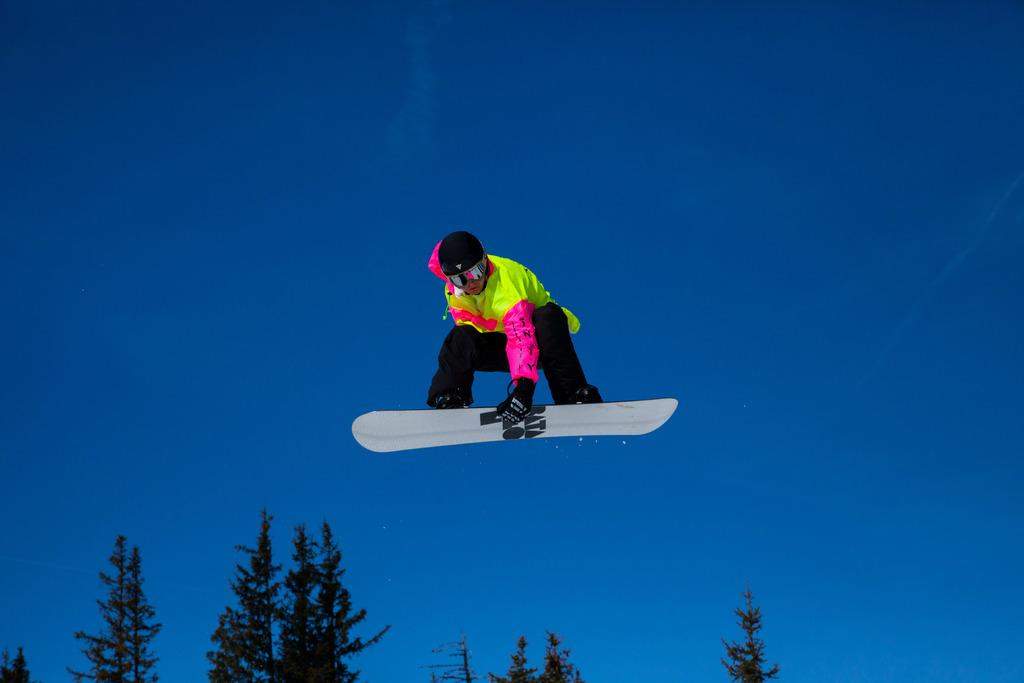What is the main subject of the image? There is a person in the image. What is the person doing in the image? The person is jumping with a snowboard. What can be seen in the background of the image? There are trees and the sky visible in the background of the image. What type of disease is affecting the person in the image? There is no indication of any disease affecting the person in the image. What kind of horn is visible on the person's snowboard? There is no horn present on the person's snowboard in the image. 